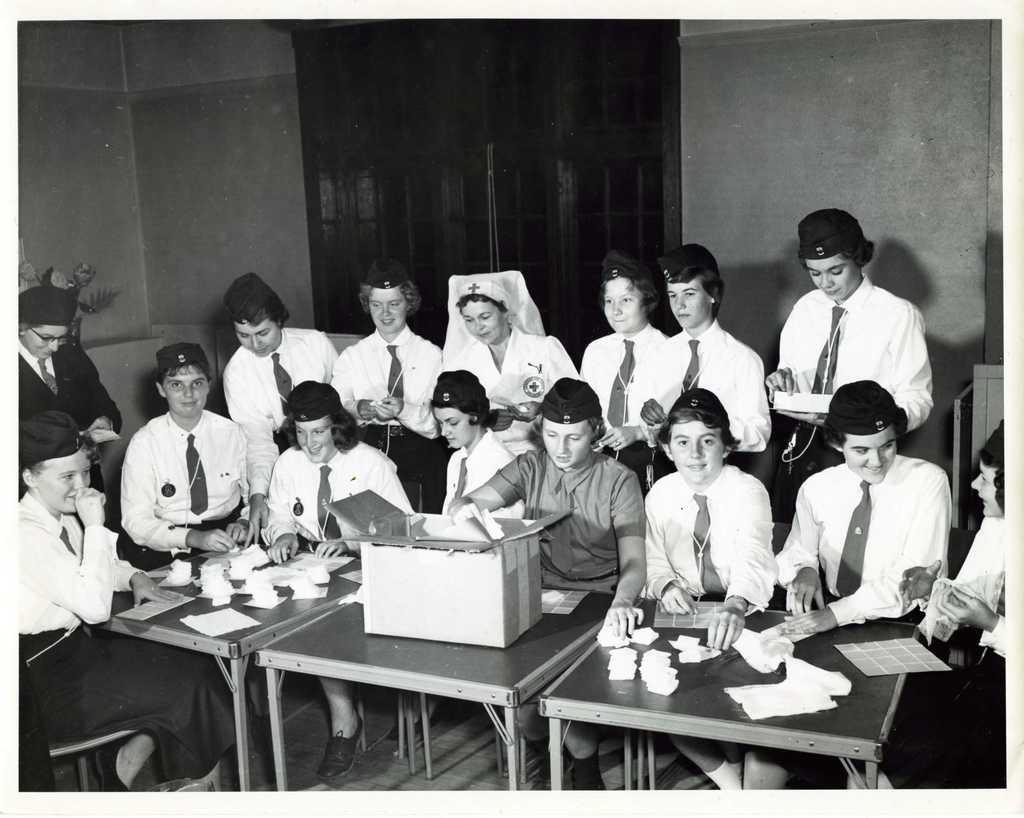How many people are in the image? There is a group of people in the image, but the exact number is not specified. What are the people in the image doing? Some people are sitting, while others are standing. What is on the table in front of the group? There is a table in the image with a box and papers on it. Can you see a rat running across the table in the image? There is no rat present in the image. 